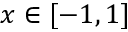Convert formula to latex. <formula><loc_0><loc_0><loc_500><loc_500>x \in [ - 1 , 1 ]</formula> 